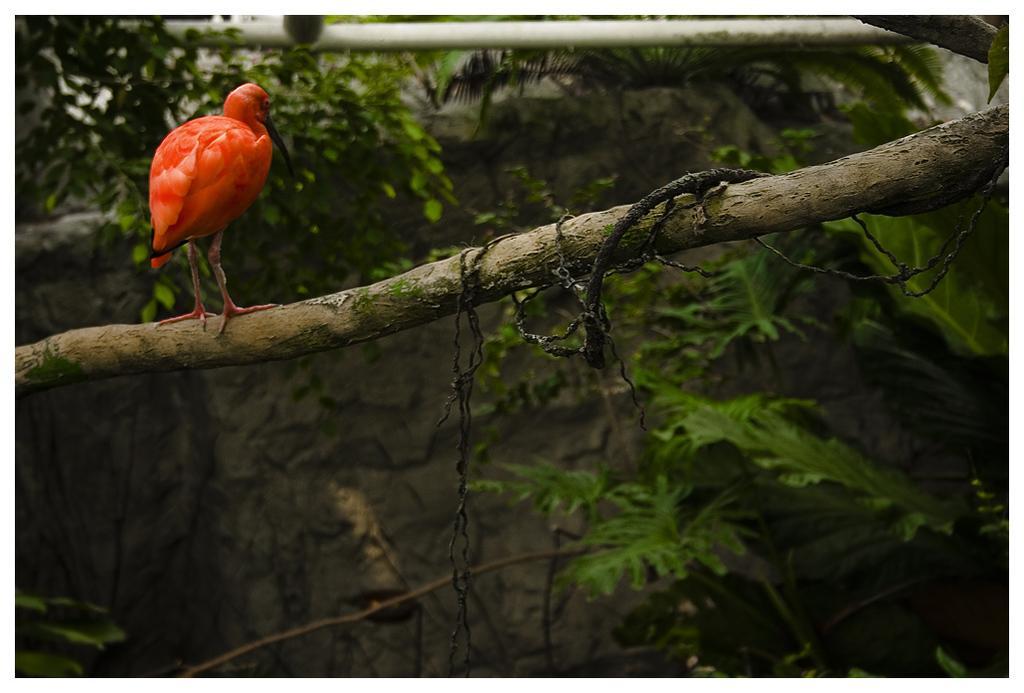Describe this image in one or two sentences. In this image, we can see a bird sitting on the stick and we can see some green plants. 